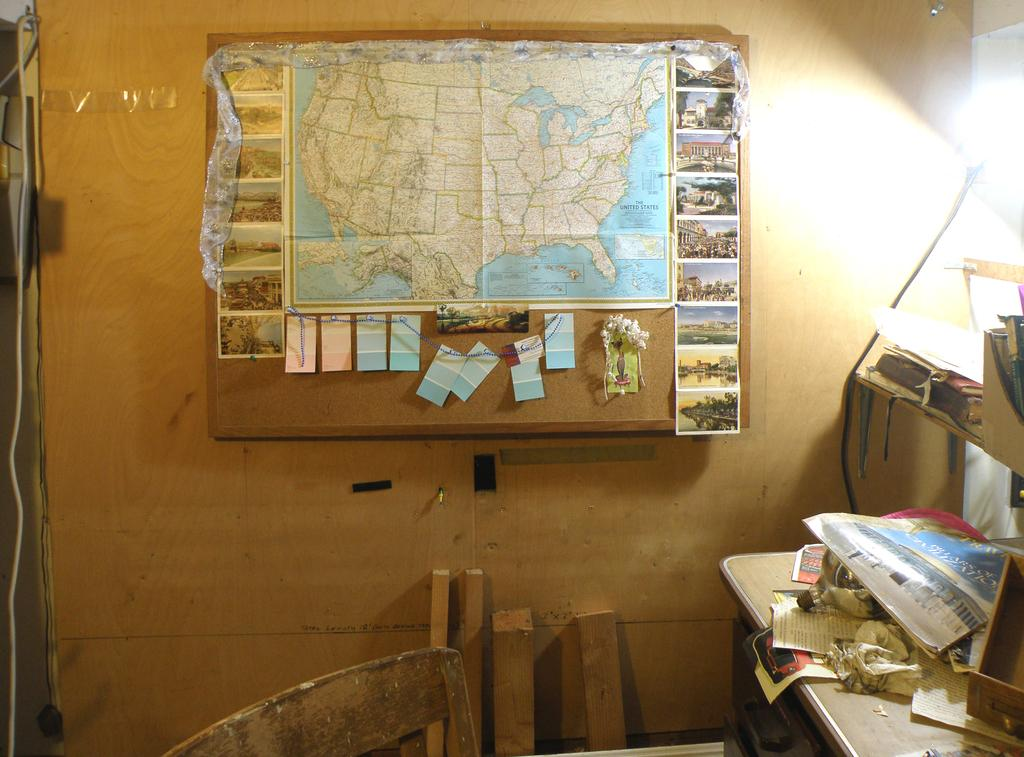What type of furniture is present in the image? There is a chair in the image. What items can be seen on the table(s) in the image? There are objects on the table(s) in the image. What type of items are on the table(s)? The objects on the table(s) include papers and a bottle. What can be seen in the background of the image? In the background of the image, there are photos and a map. What is the board attached to in the image? The board is on a wooden wall. How does the theory of relativity relate to the image? The theory of relativity is not mentioned or depicted in the image, so it cannot be related to the image. What type of cough is present in the image? There is no cough present in the image. 